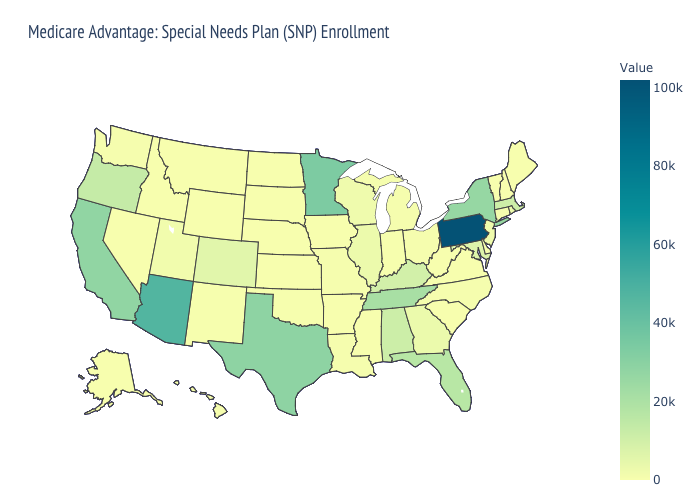Among the states that border Wyoming , which have the highest value?
Keep it brief. Colorado. Does Iowa have the lowest value in the USA?
Give a very brief answer. Yes. Which states hav the highest value in the West?
Quick response, please. Arizona. Which states hav the highest value in the South?
Quick response, please. Texas. Among the states that border Michigan , which have the lowest value?
Short answer required. Indiana. Does Pennsylvania have the highest value in the USA?
Quick response, please. Yes. 